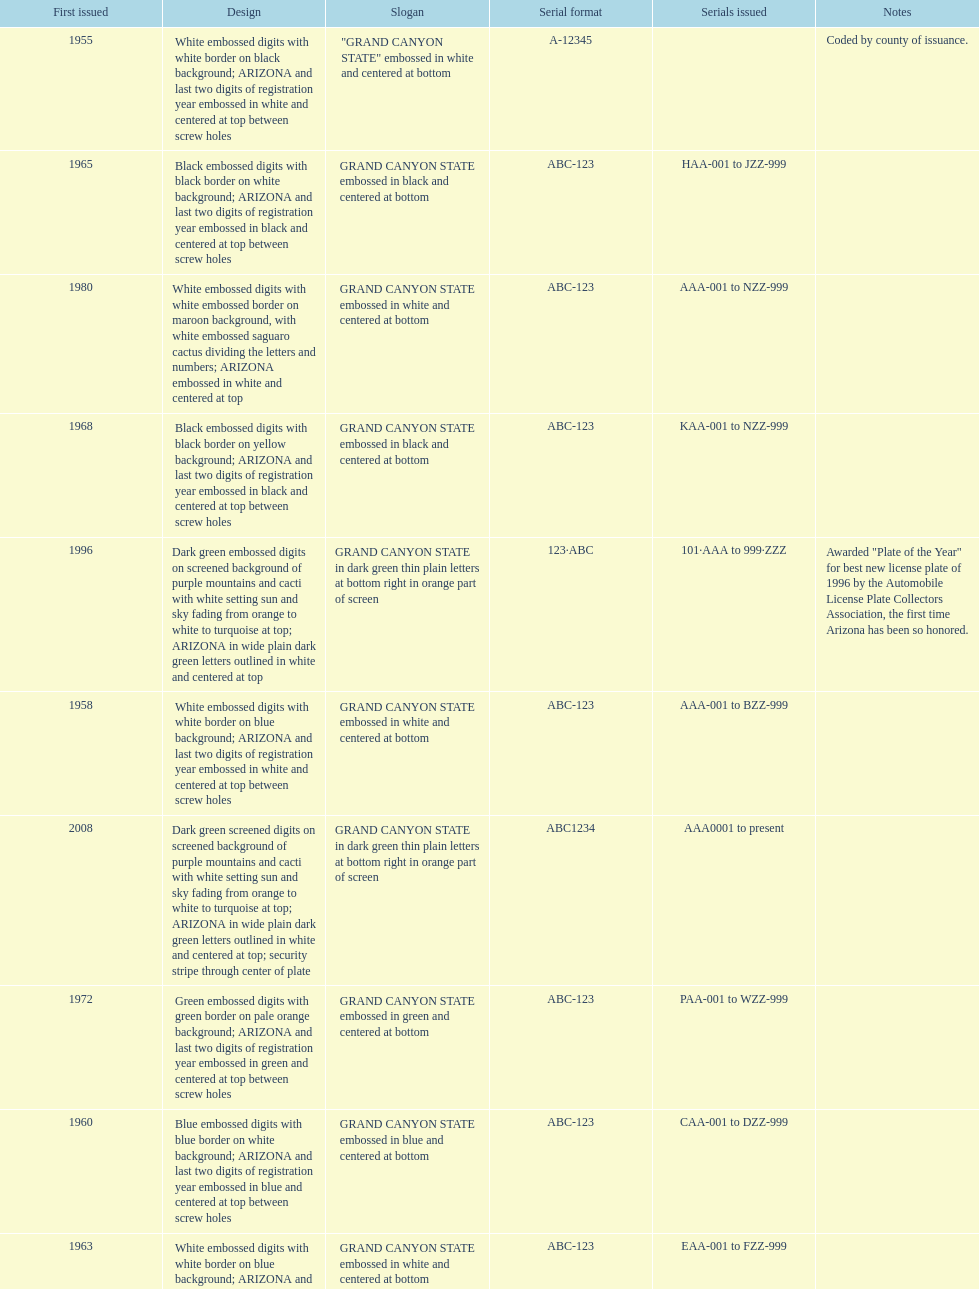Name the year of the license plate that has the largest amount of alphanumeric digits. 2008. 